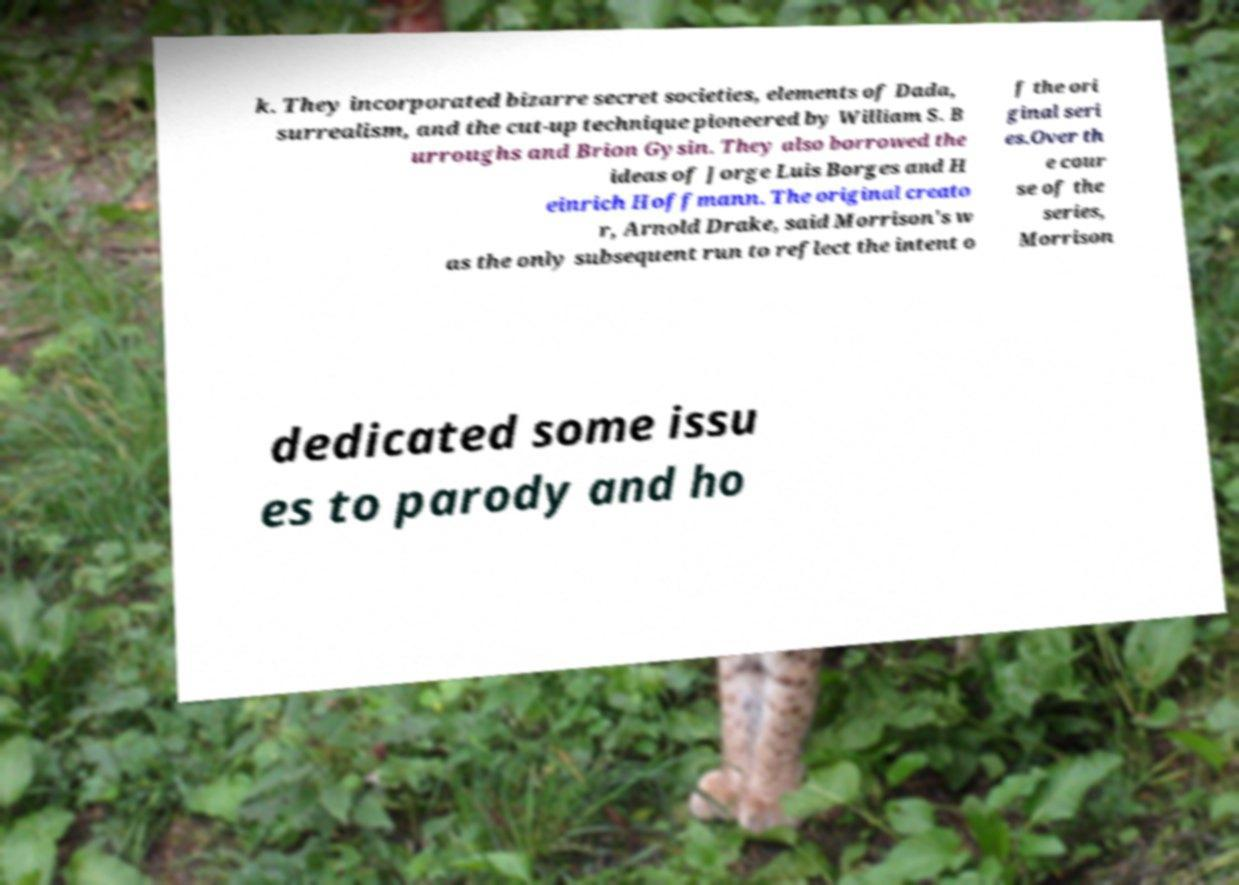Could you extract and type out the text from this image? k. They incorporated bizarre secret societies, elements of Dada, surrealism, and the cut-up technique pioneered by William S. B urroughs and Brion Gysin. They also borrowed the ideas of Jorge Luis Borges and H einrich Hoffmann. The original creato r, Arnold Drake, said Morrison's w as the only subsequent run to reflect the intent o f the ori ginal seri es.Over th e cour se of the series, Morrison dedicated some issu es to parody and ho 